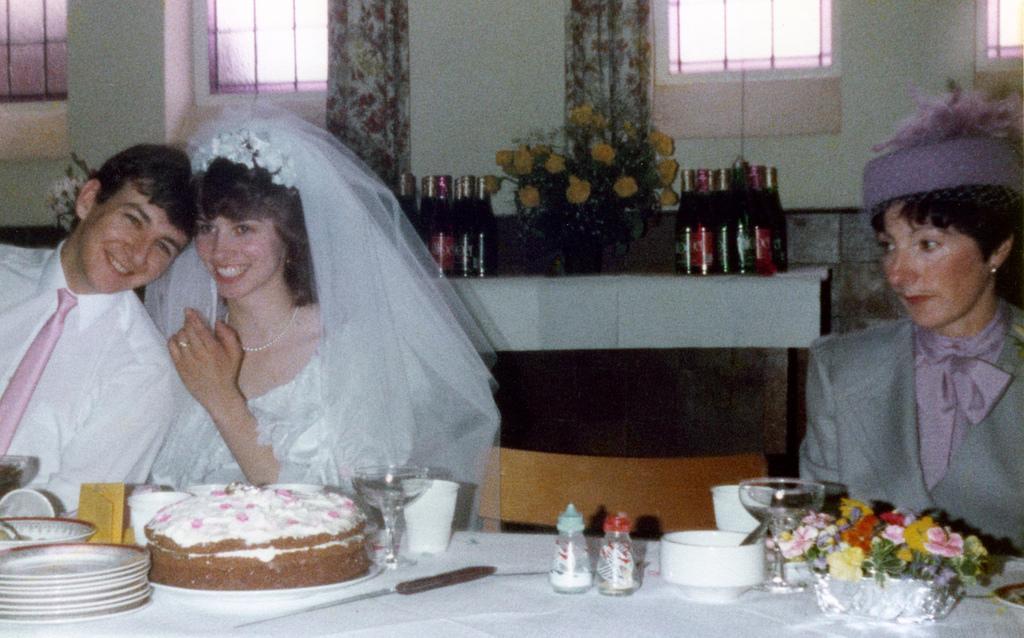Please provide a concise description of this image. In this image there are plates, glasses, bowls, a plant with flowers , cake and a knife on the table, there are three persons sitting on the chairs, and in the background there are wine bottles and a plant with flowers on the table, windows, curtains. 